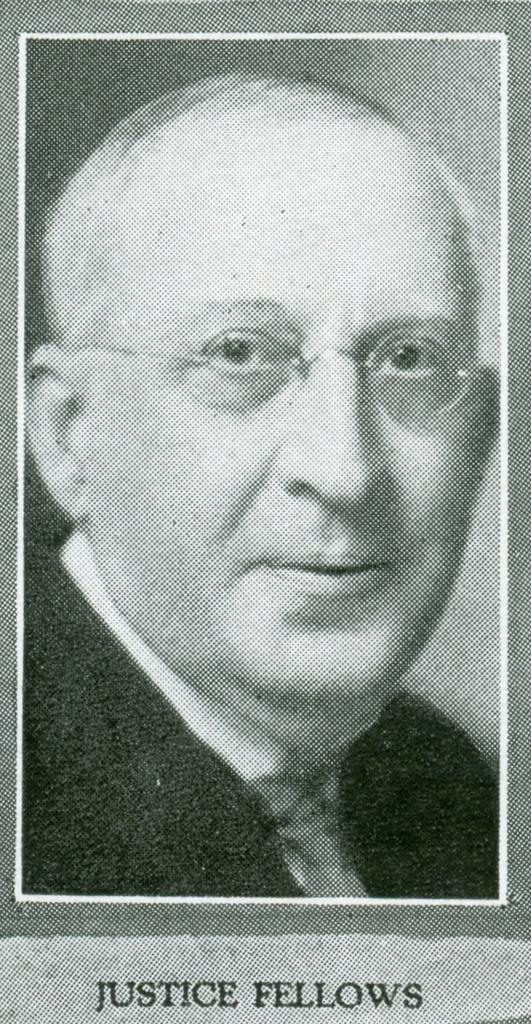What is the main subject of the image? There is a picture of a man in the image. Is there any text associated with the image? Yes, there is text at the bottom of the image. What type of plough is being used in the town depicted in the image? There is no town or plough present in the image; it features a picture of a man and text at the bottom. 